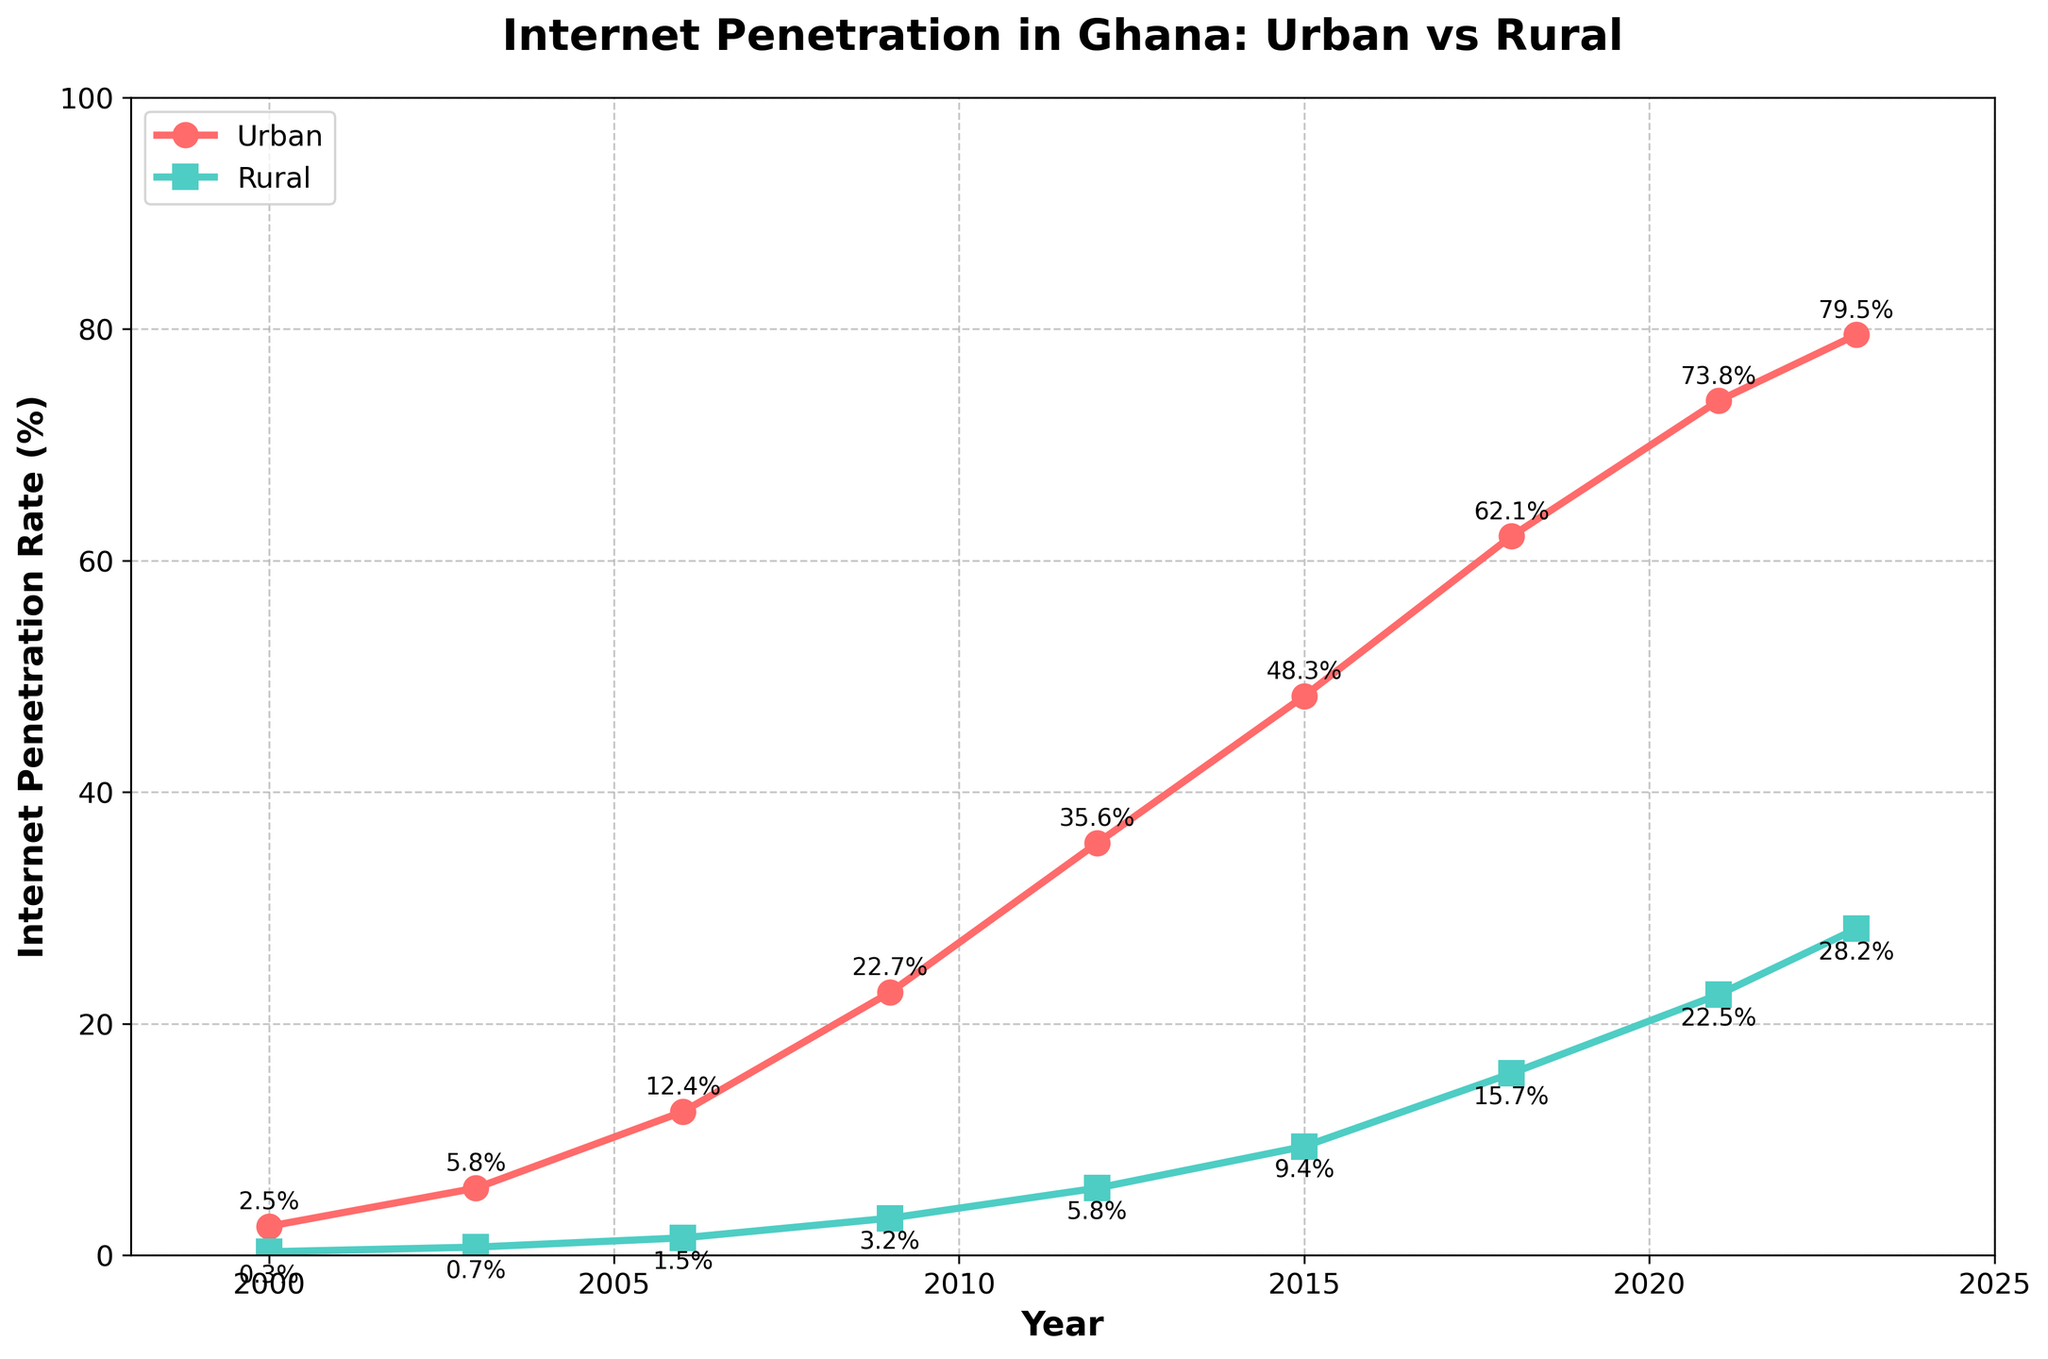what are the Internet penetration rates in urban and rural areas for the year 2006? From the line chart, locate the point corresponding to year 2006 on both the urban and rural lines. The urban penetration rate is 12.4%, and the rural penetration rate is 1.5%
Answer: Urban: 12.4%, Rural: 1.5% which area had the highest rate of internet penetration in 2023? Locate the year 2023 on the x-axis and compare the heights of the markers for urban and rural areas. The highest marker corresponds to urban areas.
Answer: Urban what is the difference in Internet penetration rates between urban and rural areas in 2009? For the year 2009, the urban rate is 22.7%, and the rural rate is 3.2%. Subtract 3.2 from 22.7 to get the difference.
Answer: 19.5% during which year did urban internet penetration exceed 50%? Look at the urban line and find the first year where the value exceeds 50%. The penetration exceeds 50% in 2015.
Answer: 2015 how does the internet penetration trend in rural areas from 2000 to 2023? Observe the rural line from the start to the end. The trend shows a steady increase in Internet penetration from 0.3% in 2000 to 28.2% in 2023.
Answer: Steady increase what's the average internet penetration rate in urban areas over the entire period? Add the urban rates for each year: 2.5 + 5.8 + 12.4 + 22.7 + 35.6 + 48.3 + 62.1 + 73.8 + 79.5 = 342.7. Divide by the number of years (9).
Answer: 38.08% in which year was the smallest gap between urban and rural internet penetration rates observed? Calculate the difference between urban and rural rates for each year and identify the smallest difference: smallest gap is 2000 (2.2%).
Answer: 2000 is the urban internet penetration rate ever equal to 75%? Check the urban line for any year where the rate is exactly 75%. The closest rate is 73.8% in 2021, but never equals 75%.
Answer: No how many years did it take for rural internet penetration rates to reach at least 15%? Find the year when the rural line first meets or exceeds 15%, which is 2018. Count the years from 2000 to 2018.
Answer: 18 years between 2018 and 2023, which area saw a higher increase in internet penetration rates? Compare the increase in rates from 2018 to 2023: Urban (79.5 - 62.1) = 17.4, Rural (28.2 - 15.7) = 12.5. Urban saw a larger increase.
Answer: Urban 